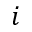<formula> <loc_0><loc_0><loc_500><loc_500>i</formula> 